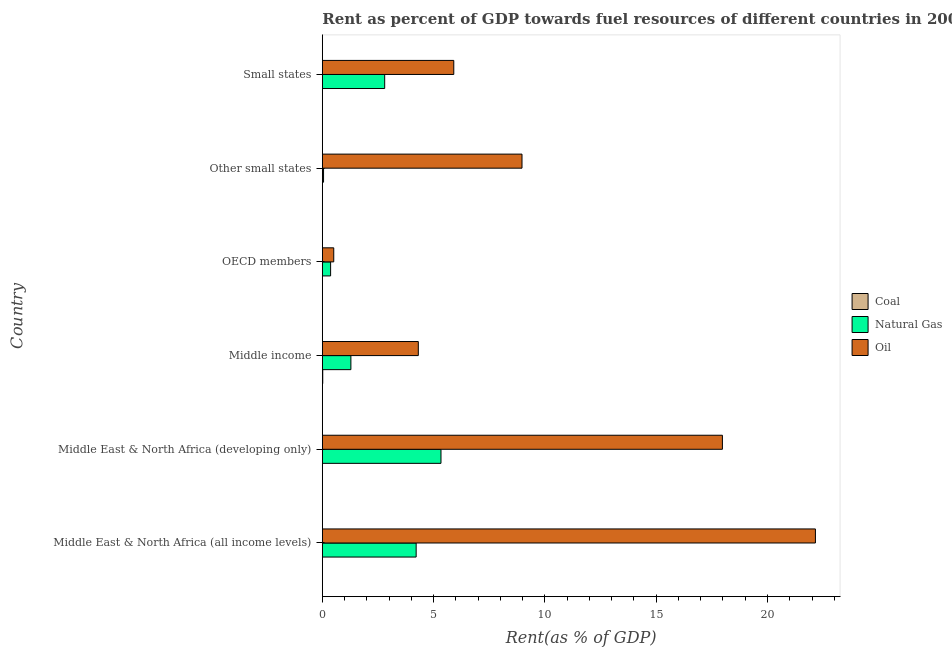How many groups of bars are there?
Your answer should be very brief. 6. Are the number of bars on each tick of the Y-axis equal?
Give a very brief answer. Yes. How many bars are there on the 2nd tick from the top?
Provide a succinct answer. 3. How many bars are there on the 1st tick from the bottom?
Keep it short and to the point. 3. What is the label of the 4th group of bars from the top?
Keep it short and to the point. Middle income. In how many cases, is the number of bars for a given country not equal to the number of legend labels?
Your answer should be very brief. 0. What is the rent towards coal in Middle income?
Your response must be concise. 0.02. Across all countries, what is the maximum rent towards natural gas?
Offer a terse response. 5.33. Across all countries, what is the minimum rent towards natural gas?
Offer a very short reply. 0.06. In which country was the rent towards natural gas maximum?
Give a very brief answer. Middle East & North Africa (developing only). What is the total rent towards natural gas in the graph?
Offer a terse response. 14.06. What is the difference between the rent towards oil in Middle East & North Africa (all income levels) and that in Other small states?
Keep it short and to the point. 13.18. What is the difference between the rent towards coal in Middle East & North Africa (all income levels) and the rent towards natural gas in Other small states?
Provide a succinct answer. -0.05. What is the average rent towards coal per country?
Provide a short and direct response. 0. What is the difference between the rent towards oil and rent towards natural gas in Middle East & North Africa (developing only)?
Offer a terse response. 12.64. What is the ratio of the rent towards natural gas in Middle East & North Africa (developing only) to that in Other small states?
Your answer should be compact. 96.89. Is the rent towards natural gas in Middle East & North Africa (developing only) less than that in Small states?
Keep it short and to the point. No. What is the difference between the highest and the second highest rent towards oil?
Make the answer very short. 4.18. In how many countries, is the rent towards oil greater than the average rent towards oil taken over all countries?
Your response must be concise. 2. What does the 1st bar from the top in OECD members represents?
Your response must be concise. Oil. What does the 3rd bar from the bottom in Middle East & North Africa (developing only) represents?
Your answer should be very brief. Oil. Is it the case that in every country, the sum of the rent towards coal and rent towards natural gas is greater than the rent towards oil?
Your response must be concise. No. Are all the bars in the graph horizontal?
Your response must be concise. Yes. What is the difference between two consecutive major ticks on the X-axis?
Your answer should be compact. 5. Are the values on the major ticks of X-axis written in scientific E-notation?
Offer a very short reply. No. Does the graph contain any zero values?
Offer a very short reply. No. Does the graph contain grids?
Your response must be concise. No. Where does the legend appear in the graph?
Ensure brevity in your answer.  Center right. What is the title of the graph?
Provide a succinct answer. Rent as percent of GDP towards fuel resources of different countries in 2000. What is the label or title of the X-axis?
Offer a very short reply. Rent(as % of GDP). What is the Rent(as % of GDP) of Coal in Middle East & North Africa (all income levels)?
Keep it short and to the point. 0. What is the Rent(as % of GDP) in Natural Gas in Middle East & North Africa (all income levels)?
Your response must be concise. 4.22. What is the Rent(as % of GDP) of Oil in Middle East & North Africa (all income levels)?
Make the answer very short. 22.15. What is the Rent(as % of GDP) of Coal in Middle East & North Africa (developing only)?
Provide a short and direct response. 0. What is the Rent(as % of GDP) in Natural Gas in Middle East & North Africa (developing only)?
Provide a short and direct response. 5.33. What is the Rent(as % of GDP) of Oil in Middle East & North Africa (developing only)?
Give a very brief answer. 17.97. What is the Rent(as % of GDP) of Coal in Middle income?
Your response must be concise. 0.02. What is the Rent(as % of GDP) of Natural Gas in Middle income?
Ensure brevity in your answer.  1.28. What is the Rent(as % of GDP) of Oil in Middle income?
Provide a succinct answer. 4.31. What is the Rent(as % of GDP) of Coal in OECD members?
Offer a very short reply. 0. What is the Rent(as % of GDP) in Natural Gas in OECD members?
Ensure brevity in your answer.  0.37. What is the Rent(as % of GDP) in Oil in OECD members?
Give a very brief answer. 0.51. What is the Rent(as % of GDP) of Coal in Other small states?
Provide a short and direct response. 0. What is the Rent(as % of GDP) of Natural Gas in Other small states?
Offer a very short reply. 0.06. What is the Rent(as % of GDP) in Oil in Other small states?
Provide a succinct answer. 8.97. What is the Rent(as % of GDP) of Coal in Small states?
Offer a very short reply. 0. What is the Rent(as % of GDP) of Natural Gas in Small states?
Keep it short and to the point. 2.8. What is the Rent(as % of GDP) in Oil in Small states?
Provide a succinct answer. 5.91. Across all countries, what is the maximum Rent(as % of GDP) of Coal?
Provide a short and direct response. 0.02. Across all countries, what is the maximum Rent(as % of GDP) in Natural Gas?
Ensure brevity in your answer.  5.33. Across all countries, what is the maximum Rent(as % of GDP) of Oil?
Offer a very short reply. 22.15. Across all countries, what is the minimum Rent(as % of GDP) in Coal?
Offer a very short reply. 0. Across all countries, what is the minimum Rent(as % of GDP) of Natural Gas?
Keep it short and to the point. 0.06. Across all countries, what is the minimum Rent(as % of GDP) of Oil?
Make the answer very short. 0.51. What is the total Rent(as % of GDP) of Coal in the graph?
Offer a terse response. 0.02. What is the total Rent(as % of GDP) in Natural Gas in the graph?
Your response must be concise. 14.06. What is the total Rent(as % of GDP) of Oil in the graph?
Your response must be concise. 59.83. What is the difference between the Rent(as % of GDP) of Coal in Middle East & North Africa (all income levels) and that in Middle East & North Africa (developing only)?
Your answer should be compact. -0. What is the difference between the Rent(as % of GDP) in Natural Gas in Middle East & North Africa (all income levels) and that in Middle East & North Africa (developing only)?
Keep it short and to the point. -1.12. What is the difference between the Rent(as % of GDP) in Oil in Middle East & North Africa (all income levels) and that in Middle East & North Africa (developing only)?
Your response must be concise. 4.18. What is the difference between the Rent(as % of GDP) of Coal in Middle East & North Africa (all income levels) and that in Middle income?
Provide a succinct answer. -0.02. What is the difference between the Rent(as % of GDP) in Natural Gas in Middle East & North Africa (all income levels) and that in Middle income?
Give a very brief answer. 2.93. What is the difference between the Rent(as % of GDP) of Oil in Middle East & North Africa (all income levels) and that in Middle income?
Your response must be concise. 17.84. What is the difference between the Rent(as % of GDP) of Natural Gas in Middle East & North Africa (all income levels) and that in OECD members?
Your answer should be very brief. 3.84. What is the difference between the Rent(as % of GDP) of Oil in Middle East & North Africa (all income levels) and that in OECD members?
Your response must be concise. 21.64. What is the difference between the Rent(as % of GDP) in Coal in Middle East & North Africa (all income levels) and that in Other small states?
Provide a short and direct response. -0. What is the difference between the Rent(as % of GDP) of Natural Gas in Middle East & North Africa (all income levels) and that in Other small states?
Your answer should be very brief. 4.16. What is the difference between the Rent(as % of GDP) of Oil in Middle East & North Africa (all income levels) and that in Other small states?
Your answer should be very brief. 13.18. What is the difference between the Rent(as % of GDP) in Coal in Middle East & North Africa (all income levels) and that in Small states?
Offer a very short reply. 0. What is the difference between the Rent(as % of GDP) of Natural Gas in Middle East & North Africa (all income levels) and that in Small states?
Keep it short and to the point. 1.41. What is the difference between the Rent(as % of GDP) of Oil in Middle East & North Africa (all income levels) and that in Small states?
Your response must be concise. 16.25. What is the difference between the Rent(as % of GDP) of Coal in Middle East & North Africa (developing only) and that in Middle income?
Give a very brief answer. -0.02. What is the difference between the Rent(as % of GDP) in Natural Gas in Middle East & North Africa (developing only) and that in Middle income?
Give a very brief answer. 4.05. What is the difference between the Rent(as % of GDP) of Oil in Middle East & North Africa (developing only) and that in Middle income?
Provide a succinct answer. 13.66. What is the difference between the Rent(as % of GDP) in Natural Gas in Middle East & North Africa (developing only) and that in OECD members?
Give a very brief answer. 4.96. What is the difference between the Rent(as % of GDP) of Oil in Middle East & North Africa (developing only) and that in OECD members?
Your response must be concise. 17.46. What is the difference between the Rent(as % of GDP) in Natural Gas in Middle East & North Africa (developing only) and that in Other small states?
Provide a succinct answer. 5.28. What is the difference between the Rent(as % of GDP) in Oil in Middle East & North Africa (developing only) and that in Other small states?
Give a very brief answer. 9. What is the difference between the Rent(as % of GDP) in Coal in Middle East & North Africa (developing only) and that in Small states?
Your answer should be very brief. 0. What is the difference between the Rent(as % of GDP) of Natural Gas in Middle East & North Africa (developing only) and that in Small states?
Provide a succinct answer. 2.53. What is the difference between the Rent(as % of GDP) in Oil in Middle East & North Africa (developing only) and that in Small states?
Provide a short and direct response. 12.07. What is the difference between the Rent(as % of GDP) of Coal in Middle income and that in OECD members?
Your response must be concise. 0.02. What is the difference between the Rent(as % of GDP) of Natural Gas in Middle income and that in OECD members?
Provide a short and direct response. 0.91. What is the difference between the Rent(as % of GDP) in Oil in Middle income and that in OECD members?
Provide a short and direct response. 3.8. What is the difference between the Rent(as % of GDP) of Coal in Middle income and that in Other small states?
Provide a succinct answer. 0.02. What is the difference between the Rent(as % of GDP) in Natural Gas in Middle income and that in Other small states?
Offer a terse response. 1.23. What is the difference between the Rent(as % of GDP) of Oil in Middle income and that in Other small states?
Your answer should be compact. -4.66. What is the difference between the Rent(as % of GDP) of Coal in Middle income and that in Small states?
Your answer should be very brief. 0.02. What is the difference between the Rent(as % of GDP) of Natural Gas in Middle income and that in Small states?
Your response must be concise. -1.52. What is the difference between the Rent(as % of GDP) of Oil in Middle income and that in Small states?
Ensure brevity in your answer.  -1.59. What is the difference between the Rent(as % of GDP) of Coal in OECD members and that in Other small states?
Make the answer very short. -0. What is the difference between the Rent(as % of GDP) in Natural Gas in OECD members and that in Other small states?
Offer a terse response. 0.32. What is the difference between the Rent(as % of GDP) in Oil in OECD members and that in Other small states?
Make the answer very short. -8.46. What is the difference between the Rent(as % of GDP) in Coal in OECD members and that in Small states?
Ensure brevity in your answer.  -0. What is the difference between the Rent(as % of GDP) in Natural Gas in OECD members and that in Small states?
Make the answer very short. -2.43. What is the difference between the Rent(as % of GDP) of Oil in OECD members and that in Small states?
Provide a short and direct response. -5.39. What is the difference between the Rent(as % of GDP) in Natural Gas in Other small states and that in Small states?
Provide a succinct answer. -2.75. What is the difference between the Rent(as % of GDP) in Oil in Other small states and that in Small states?
Your response must be concise. 3.06. What is the difference between the Rent(as % of GDP) in Coal in Middle East & North Africa (all income levels) and the Rent(as % of GDP) in Natural Gas in Middle East & North Africa (developing only)?
Your answer should be very brief. -5.33. What is the difference between the Rent(as % of GDP) in Coal in Middle East & North Africa (all income levels) and the Rent(as % of GDP) in Oil in Middle East & North Africa (developing only)?
Keep it short and to the point. -17.97. What is the difference between the Rent(as % of GDP) in Natural Gas in Middle East & North Africa (all income levels) and the Rent(as % of GDP) in Oil in Middle East & North Africa (developing only)?
Offer a very short reply. -13.76. What is the difference between the Rent(as % of GDP) of Coal in Middle East & North Africa (all income levels) and the Rent(as % of GDP) of Natural Gas in Middle income?
Your response must be concise. -1.28. What is the difference between the Rent(as % of GDP) of Coal in Middle East & North Africa (all income levels) and the Rent(as % of GDP) of Oil in Middle income?
Offer a very short reply. -4.31. What is the difference between the Rent(as % of GDP) of Natural Gas in Middle East & North Africa (all income levels) and the Rent(as % of GDP) of Oil in Middle income?
Keep it short and to the point. -0.1. What is the difference between the Rent(as % of GDP) of Coal in Middle East & North Africa (all income levels) and the Rent(as % of GDP) of Natural Gas in OECD members?
Your answer should be very brief. -0.37. What is the difference between the Rent(as % of GDP) of Coal in Middle East & North Africa (all income levels) and the Rent(as % of GDP) of Oil in OECD members?
Provide a succinct answer. -0.51. What is the difference between the Rent(as % of GDP) in Natural Gas in Middle East & North Africa (all income levels) and the Rent(as % of GDP) in Oil in OECD members?
Provide a short and direct response. 3.7. What is the difference between the Rent(as % of GDP) of Coal in Middle East & North Africa (all income levels) and the Rent(as % of GDP) of Natural Gas in Other small states?
Make the answer very short. -0.05. What is the difference between the Rent(as % of GDP) in Coal in Middle East & North Africa (all income levels) and the Rent(as % of GDP) in Oil in Other small states?
Provide a succinct answer. -8.97. What is the difference between the Rent(as % of GDP) of Natural Gas in Middle East & North Africa (all income levels) and the Rent(as % of GDP) of Oil in Other small states?
Provide a succinct answer. -4.76. What is the difference between the Rent(as % of GDP) of Coal in Middle East & North Africa (all income levels) and the Rent(as % of GDP) of Natural Gas in Small states?
Offer a terse response. -2.8. What is the difference between the Rent(as % of GDP) in Coal in Middle East & North Africa (all income levels) and the Rent(as % of GDP) in Oil in Small states?
Your answer should be compact. -5.91. What is the difference between the Rent(as % of GDP) of Natural Gas in Middle East & North Africa (all income levels) and the Rent(as % of GDP) of Oil in Small states?
Your response must be concise. -1.69. What is the difference between the Rent(as % of GDP) of Coal in Middle East & North Africa (developing only) and the Rent(as % of GDP) of Natural Gas in Middle income?
Provide a short and direct response. -1.28. What is the difference between the Rent(as % of GDP) of Coal in Middle East & North Africa (developing only) and the Rent(as % of GDP) of Oil in Middle income?
Provide a succinct answer. -4.31. What is the difference between the Rent(as % of GDP) in Natural Gas in Middle East & North Africa (developing only) and the Rent(as % of GDP) in Oil in Middle income?
Provide a succinct answer. 1.02. What is the difference between the Rent(as % of GDP) of Coal in Middle East & North Africa (developing only) and the Rent(as % of GDP) of Natural Gas in OECD members?
Offer a terse response. -0.37. What is the difference between the Rent(as % of GDP) of Coal in Middle East & North Africa (developing only) and the Rent(as % of GDP) of Oil in OECD members?
Keep it short and to the point. -0.51. What is the difference between the Rent(as % of GDP) in Natural Gas in Middle East & North Africa (developing only) and the Rent(as % of GDP) in Oil in OECD members?
Offer a terse response. 4.82. What is the difference between the Rent(as % of GDP) of Coal in Middle East & North Africa (developing only) and the Rent(as % of GDP) of Natural Gas in Other small states?
Offer a very short reply. -0.05. What is the difference between the Rent(as % of GDP) in Coal in Middle East & North Africa (developing only) and the Rent(as % of GDP) in Oil in Other small states?
Offer a very short reply. -8.97. What is the difference between the Rent(as % of GDP) of Natural Gas in Middle East & North Africa (developing only) and the Rent(as % of GDP) of Oil in Other small states?
Your answer should be very brief. -3.64. What is the difference between the Rent(as % of GDP) of Coal in Middle East & North Africa (developing only) and the Rent(as % of GDP) of Natural Gas in Small states?
Offer a terse response. -2.8. What is the difference between the Rent(as % of GDP) of Coal in Middle East & North Africa (developing only) and the Rent(as % of GDP) of Oil in Small states?
Provide a short and direct response. -5.91. What is the difference between the Rent(as % of GDP) in Natural Gas in Middle East & North Africa (developing only) and the Rent(as % of GDP) in Oil in Small states?
Ensure brevity in your answer.  -0.58. What is the difference between the Rent(as % of GDP) of Coal in Middle income and the Rent(as % of GDP) of Natural Gas in OECD members?
Provide a short and direct response. -0.35. What is the difference between the Rent(as % of GDP) in Coal in Middle income and the Rent(as % of GDP) in Oil in OECD members?
Your answer should be compact. -0.49. What is the difference between the Rent(as % of GDP) of Natural Gas in Middle income and the Rent(as % of GDP) of Oil in OECD members?
Provide a succinct answer. 0.77. What is the difference between the Rent(as % of GDP) in Coal in Middle income and the Rent(as % of GDP) in Natural Gas in Other small states?
Offer a terse response. -0.04. What is the difference between the Rent(as % of GDP) in Coal in Middle income and the Rent(as % of GDP) in Oil in Other small states?
Provide a short and direct response. -8.95. What is the difference between the Rent(as % of GDP) of Natural Gas in Middle income and the Rent(as % of GDP) of Oil in Other small states?
Provide a short and direct response. -7.69. What is the difference between the Rent(as % of GDP) in Coal in Middle income and the Rent(as % of GDP) in Natural Gas in Small states?
Provide a succinct answer. -2.78. What is the difference between the Rent(as % of GDP) in Coal in Middle income and the Rent(as % of GDP) in Oil in Small states?
Provide a succinct answer. -5.89. What is the difference between the Rent(as % of GDP) of Natural Gas in Middle income and the Rent(as % of GDP) of Oil in Small states?
Your answer should be compact. -4.62. What is the difference between the Rent(as % of GDP) in Coal in OECD members and the Rent(as % of GDP) in Natural Gas in Other small states?
Make the answer very short. -0.05. What is the difference between the Rent(as % of GDP) of Coal in OECD members and the Rent(as % of GDP) of Oil in Other small states?
Provide a succinct answer. -8.97. What is the difference between the Rent(as % of GDP) of Natural Gas in OECD members and the Rent(as % of GDP) of Oil in Other small states?
Keep it short and to the point. -8.6. What is the difference between the Rent(as % of GDP) in Coal in OECD members and the Rent(as % of GDP) in Natural Gas in Small states?
Your response must be concise. -2.8. What is the difference between the Rent(as % of GDP) of Coal in OECD members and the Rent(as % of GDP) of Oil in Small states?
Offer a very short reply. -5.91. What is the difference between the Rent(as % of GDP) of Natural Gas in OECD members and the Rent(as % of GDP) of Oil in Small states?
Keep it short and to the point. -5.53. What is the difference between the Rent(as % of GDP) in Coal in Other small states and the Rent(as % of GDP) in Natural Gas in Small states?
Your response must be concise. -2.8. What is the difference between the Rent(as % of GDP) of Coal in Other small states and the Rent(as % of GDP) of Oil in Small states?
Keep it short and to the point. -5.91. What is the difference between the Rent(as % of GDP) of Natural Gas in Other small states and the Rent(as % of GDP) of Oil in Small states?
Offer a terse response. -5.85. What is the average Rent(as % of GDP) of Coal per country?
Keep it short and to the point. 0. What is the average Rent(as % of GDP) of Natural Gas per country?
Give a very brief answer. 2.34. What is the average Rent(as % of GDP) of Oil per country?
Ensure brevity in your answer.  9.97. What is the difference between the Rent(as % of GDP) in Coal and Rent(as % of GDP) in Natural Gas in Middle East & North Africa (all income levels)?
Your answer should be compact. -4.22. What is the difference between the Rent(as % of GDP) of Coal and Rent(as % of GDP) of Oil in Middle East & North Africa (all income levels)?
Your response must be concise. -22.15. What is the difference between the Rent(as % of GDP) in Natural Gas and Rent(as % of GDP) in Oil in Middle East & North Africa (all income levels)?
Provide a short and direct response. -17.94. What is the difference between the Rent(as % of GDP) of Coal and Rent(as % of GDP) of Natural Gas in Middle East & North Africa (developing only)?
Offer a terse response. -5.33. What is the difference between the Rent(as % of GDP) of Coal and Rent(as % of GDP) of Oil in Middle East & North Africa (developing only)?
Your response must be concise. -17.97. What is the difference between the Rent(as % of GDP) in Natural Gas and Rent(as % of GDP) in Oil in Middle East & North Africa (developing only)?
Provide a succinct answer. -12.64. What is the difference between the Rent(as % of GDP) in Coal and Rent(as % of GDP) in Natural Gas in Middle income?
Give a very brief answer. -1.26. What is the difference between the Rent(as % of GDP) of Coal and Rent(as % of GDP) of Oil in Middle income?
Provide a succinct answer. -4.29. What is the difference between the Rent(as % of GDP) of Natural Gas and Rent(as % of GDP) of Oil in Middle income?
Keep it short and to the point. -3.03. What is the difference between the Rent(as % of GDP) of Coal and Rent(as % of GDP) of Natural Gas in OECD members?
Keep it short and to the point. -0.37. What is the difference between the Rent(as % of GDP) in Coal and Rent(as % of GDP) in Oil in OECD members?
Your answer should be compact. -0.51. What is the difference between the Rent(as % of GDP) of Natural Gas and Rent(as % of GDP) of Oil in OECD members?
Your answer should be very brief. -0.14. What is the difference between the Rent(as % of GDP) of Coal and Rent(as % of GDP) of Natural Gas in Other small states?
Your answer should be very brief. -0.05. What is the difference between the Rent(as % of GDP) of Coal and Rent(as % of GDP) of Oil in Other small states?
Provide a succinct answer. -8.97. What is the difference between the Rent(as % of GDP) of Natural Gas and Rent(as % of GDP) of Oil in Other small states?
Keep it short and to the point. -8.92. What is the difference between the Rent(as % of GDP) of Coal and Rent(as % of GDP) of Natural Gas in Small states?
Ensure brevity in your answer.  -2.8. What is the difference between the Rent(as % of GDP) in Coal and Rent(as % of GDP) in Oil in Small states?
Your answer should be compact. -5.91. What is the difference between the Rent(as % of GDP) in Natural Gas and Rent(as % of GDP) in Oil in Small states?
Keep it short and to the point. -3.1. What is the ratio of the Rent(as % of GDP) in Coal in Middle East & North Africa (all income levels) to that in Middle East & North Africa (developing only)?
Give a very brief answer. 0.45. What is the ratio of the Rent(as % of GDP) of Natural Gas in Middle East & North Africa (all income levels) to that in Middle East & North Africa (developing only)?
Offer a terse response. 0.79. What is the ratio of the Rent(as % of GDP) of Oil in Middle East & North Africa (all income levels) to that in Middle East & North Africa (developing only)?
Make the answer very short. 1.23. What is the ratio of the Rent(as % of GDP) in Coal in Middle East & North Africa (all income levels) to that in Middle income?
Provide a short and direct response. 0.01. What is the ratio of the Rent(as % of GDP) of Natural Gas in Middle East & North Africa (all income levels) to that in Middle income?
Keep it short and to the point. 3.28. What is the ratio of the Rent(as % of GDP) in Oil in Middle East & North Africa (all income levels) to that in Middle income?
Make the answer very short. 5.14. What is the ratio of the Rent(as % of GDP) in Coal in Middle East & North Africa (all income levels) to that in OECD members?
Make the answer very short. 2.31. What is the ratio of the Rent(as % of GDP) of Natural Gas in Middle East & North Africa (all income levels) to that in OECD members?
Ensure brevity in your answer.  11.33. What is the ratio of the Rent(as % of GDP) in Oil in Middle East & North Africa (all income levels) to that in OECD members?
Offer a terse response. 43.18. What is the ratio of the Rent(as % of GDP) in Coal in Middle East & North Africa (all income levels) to that in Other small states?
Offer a terse response. 0.81. What is the ratio of the Rent(as % of GDP) of Natural Gas in Middle East & North Africa (all income levels) to that in Other small states?
Make the answer very short. 76.62. What is the ratio of the Rent(as % of GDP) of Oil in Middle East & North Africa (all income levels) to that in Other small states?
Ensure brevity in your answer.  2.47. What is the ratio of the Rent(as % of GDP) of Coal in Middle East & North Africa (all income levels) to that in Small states?
Provide a short and direct response. 1.87. What is the ratio of the Rent(as % of GDP) of Natural Gas in Middle East & North Africa (all income levels) to that in Small states?
Give a very brief answer. 1.5. What is the ratio of the Rent(as % of GDP) of Oil in Middle East & North Africa (all income levels) to that in Small states?
Make the answer very short. 3.75. What is the ratio of the Rent(as % of GDP) of Coal in Middle East & North Africa (developing only) to that in Middle income?
Keep it short and to the point. 0.03. What is the ratio of the Rent(as % of GDP) of Natural Gas in Middle East & North Africa (developing only) to that in Middle income?
Provide a short and direct response. 4.15. What is the ratio of the Rent(as % of GDP) of Oil in Middle East & North Africa (developing only) to that in Middle income?
Your response must be concise. 4.17. What is the ratio of the Rent(as % of GDP) of Coal in Middle East & North Africa (developing only) to that in OECD members?
Offer a very short reply. 5.13. What is the ratio of the Rent(as % of GDP) of Natural Gas in Middle East & North Africa (developing only) to that in OECD members?
Give a very brief answer. 14.33. What is the ratio of the Rent(as % of GDP) of Oil in Middle East & North Africa (developing only) to that in OECD members?
Provide a short and direct response. 35.03. What is the ratio of the Rent(as % of GDP) in Coal in Middle East & North Africa (developing only) to that in Other small states?
Offer a very short reply. 1.79. What is the ratio of the Rent(as % of GDP) in Natural Gas in Middle East & North Africa (developing only) to that in Other small states?
Provide a short and direct response. 96.89. What is the ratio of the Rent(as % of GDP) of Oil in Middle East & North Africa (developing only) to that in Other small states?
Your answer should be compact. 2. What is the ratio of the Rent(as % of GDP) of Coal in Middle East & North Africa (developing only) to that in Small states?
Your response must be concise. 4.15. What is the ratio of the Rent(as % of GDP) of Natural Gas in Middle East & North Africa (developing only) to that in Small states?
Give a very brief answer. 1.9. What is the ratio of the Rent(as % of GDP) in Oil in Middle East & North Africa (developing only) to that in Small states?
Offer a very short reply. 3.04. What is the ratio of the Rent(as % of GDP) of Coal in Middle income to that in OECD members?
Provide a short and direct response. 154.82. What is the ratio of the Rent(as % of GDP) in Natural Gas in Middle income to that in OECD members?
Offer a terse response. 3.45. What is the ratio of the Rent(as % of GDP) of Oil in Middle income to that in OECD members?
Provide a short and direct response. 8.41. What is the ratio of the Rent(as % of GDP) in Coal in Middle income to that in Other small states?
Your answer should be compact. 54.12. What is the ratio of the Rent(as % of GDP) in Natural Gas in Middle income to that in Other small states?
Ensure brevity in your answer.  23.33. What is the ratio of the Rent(as % of GDP) of Oil in Middle income to that in Other small states?
Offer a terse response. 0.48. What is the ratio of the Rent(as % of GDP) of Coal in Middle income to that in Small states?
Your response must be concise. 125.23. What is the ratio of the Rent(as % of GDP) in Natural Gas in Middle income to that in Small states?
Your answer should be compact. 0.46. What is the ratio of the Rent(as % of GDP) of Oil in Middle income to that in Small states?
Keep it short and to the point. 0.73. What is the ratio of the Rent(as % of GDP) in Coal in OECD members to that in Other small states?
Provide a succinct answer. 0.35. What is the ratio of the Rent(as % of GDP) in Natural Gas in OECD members to that in Other small states?
Your response must be concise. 6.76. What is the ratio of the Rent(as % of GDP) in Oil in OECD members to that in Other small states?
Offer a terse response. 0.06. What is the ratio of the Rent(as % of GDP) of Coal in OECD members to that in Small states?
Give a very brief answer. 0.81. What is the ratio of the Rent(as % of GDP) in Natural Gas in OECD members to that in Small states?
Keep it short and to the point. 0.13. What is the ratio of the Rent(as % of GDP) of Oil in OECD members to that in Small states?
Your answer should be compact. 0.09. What is the ratio of the Rent(as % of GDP) of Coal in Other small states to that in Small states?
Make the answer very short. 2.31. What is the ratio of the Rent(as % of GDP) of Natural Gas in Other small states to that in Small states?
Your answer should be compact. 0.02. What is the ratio of the Rent(as % of GDP) of Oil in Other small states to that in Small states?
Provide a succinct answer. 1.52. What is the difference between the highest and the second highest Rent(as % of GDP) of Coal?
Your response must be concise. 0.02. What is the difference between the highest and the second highest Rent(as % of GDP) of Natural Gas?
Offer a terse response. 1.12. What is the difference between the highest and the second highest Rent(as % of GDP) in Oil?
Keep it short and to the point. 4.18. What is the difference between the highest and the lowest Rent(as % of GDP) of Coal?
Give a very brief answer. 0.02. What is the difference between the highest and the lowest Rent(as % of GDP) in Natural Gas?
Keep it short and to the point. 5.28. What is the difference between the highest and the lowest Rent(as % of GDP) in Oil?
Your answer should be very brief. 21.64. 